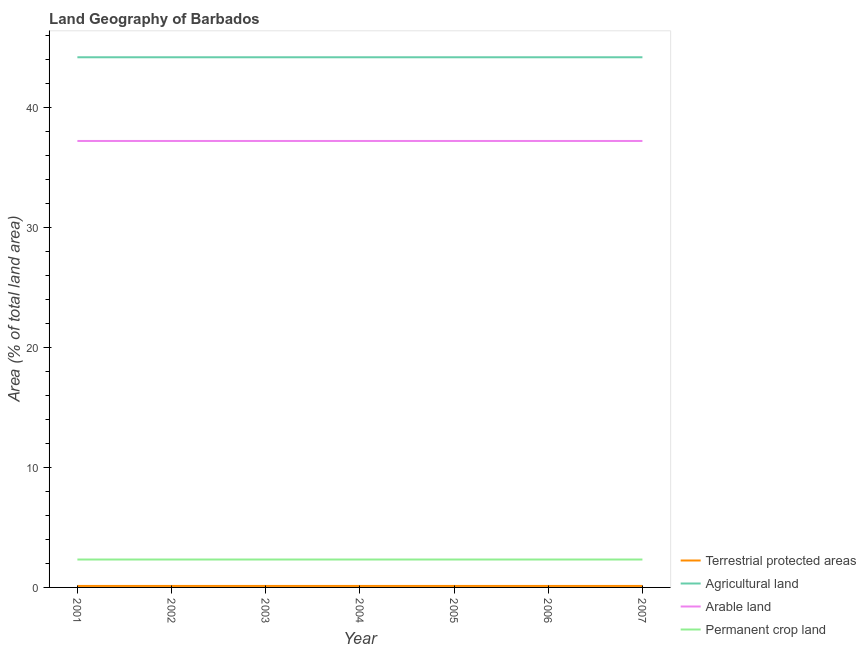Does the line corresponding to percentage of area under permanent crop land intersect with the line corresponding to percentage of area under arable land?
Give a very brief answer. No. What is the percentage of area under arable land in 2003?
Your answer should be compact. 37.21. Across all years, what is the maximum percentage of area under agricultural land?
Offer a terse response. 44.19. Across all years, what is the minimum percentage of land under terrestrial protection?
Provide a short and direct response. 0.12. In which year was the percentage of area under arable land maximum?
Provide a succinct answer. 2001. In which year was the percentage of area under arable land minimum?
Your answer should be very brief. 2001. What is the total percentage of area under arable land in the graph?
Ensure brevity in your answer.  260.47. What is the difference between the percentage of area under agricultural land in 2003 and that in 2004?
Your answer should be very brief. 0. What is the difference between the percentage of area under permanent crop land in 2001 and the percentage of land under terrestrial protection in 2006?
Ensure brevity in your answer.  2.2. What is the average percentage of area under arable land per year?
Your answer should be very brief. 37.21. In the year 2004, what is the difference between the percentage of area under permanent crop land and percentage of area under arable land?
Ensure brevity in your answer.  -34.88. What is the ratio of the percentage of area under agricultural land in 2003 to that in 2007?
Your answer should be very brief. 1. Is the percentage of area under arable land in 2002 less than that in 2005?
Keep it short and to the point. No. What is the difference between the highest and the lowest percentage of area under agricultural land?
Keep it short and to the point. 0. In how many years, is the percentage of area under permanent crop land greater than the average percentage of area under permanent crop land taken over all years?
Offer a terse response. 0. Is the sum of the percentage of area under agricultural land in 2004 and 2007 greater than the maximum percentage of area under permanent crop land across all years?
Give a very brief answer. Yes. Is it the case that in every year, the sum of the percentage of land under terrestrial protection and percentage of area under agricultural land is greater than the percentage of area under arable land?
Your answer should be compact. Yes. What is the difference between two consecutive major ticks on the Y-axis?
Offer a terse response. 10. Where does the legend appear in the graph?
Your response must be concise. Bottom right. What is the title of the graph?
Offer a terse response. Land Geography of Barbados. Does "Fish species" appear as one of the legend labels in the graph?
Give a very brief answer. No. What is the label or title of the Y-axis?
Your answer should be compact. Area (% of total land area). What is the Area (% of total land area) of Terrestrial protected areas in 2001?
Ensure brevity in your answer.  0.12. What is the Area (% of total land area) in Agricultural land in 2001?
Your answer should be very brief. 44.19. What is the Area (% of total land area) in Arable land in 2001?
Keep it short and to the point. 37.21. What is the Area (% of total land area) of Permanent crop land in 2001?
Make the answer very short. 2.33. What is the Area (% of total land area) of Terrestrial protected areas in 2002?
Provide a short and direct response. 0.12. What is the Area (% of total land area) of Agricultural land in 2002?
Ensure brevity in your answer.  44.19. What is the Area (% of total land area) in Arable land in 2002?
Give a very brief answer. 37.21. What is the Area (% of total land area) in Permanent crop land in 2002?
Provide a succinct answer. 2.33. What is the Area (% of total land area) of Terrestrial protected areas in 2003?
Provide a succinct answer. 0.12. What is the Area (% of total land area) of Agricultural land in 2003?
Offer a very short reply. 44.19. What is the Area (% of total land area) of Arable land in 2003?
Provide a short and direct response. 37.21. What is the Area (% of total land area) in Permanent crop land in 2003?
Provide a short and direct response. 2.33. What is the Area (% of total land area) in Terrestrial protected areas in 2004?
Make the answer very short. 0.12. What is the Area (% of total land area) in Agricultural land in 2004?
Provide a succinct answer. 44.19. What is the Area (% of total land area) of Arable land in 2004?
Provide a succinct answer. 37.21. What is the Area (% of total land area) of Permanent crop land in 2004?
Your response must be concise. 2.33. What is the Area (% of total land area) of Terrestrial protected areas in 2005?
Your answer should be compact. 0.12. What is the Area (% of total land area) in Agricultural land in 2005?
Keep it short and to the point. 44.19. What is the Area (% of total land area) in Arable land in 2005?
Offer a very short reply. 37.21. What is the Area (% of total land area) of Permanent crop land in 2005?
Keep it short and to the point. 2.33. What is the Area (% of total land area) in Terrestrial protected areas in 2006?
Make the answer very short. 0.12. What is the Area (% of total land area) in Agricultural land in 2006?
Make the answer very short. 44.19. What is the Area (% of total land area) in Arable land in 2006?
Provide a succinct answer. 37.21. What is the Area (% of total land area) in Permanent crop land in 2006?
Offer a very short reply. 2.33. What is the Area (% of total land area) of Terrestrial protected areas in 2007?
Offer a very short reply. 0.12. What is the Area (% of total land area) of Agricultural land in 2007?
Provide a short and direct response. 44.19. What is the Area (% of total land area) of Arable land in 2007?
Give a very brief answer. 37.21. What is the Area (% of total land area) in Permanent crop land in 2007?
Your answer should be compact. 2.33. Across all years, what is the maximum Area (% of total land area) of Terrestrial protected areas?
Make the answer very short. 0.12. Across all years, what is the maximum Area (% of total land area) of Agricultural land?
Offer a very short reply. 44.19. Across all years, what is the maximum Area (% of total land area) in Arable land?
Ensure brevity in your answer.  37.21. Across all years, what is the maximum Area (% of total land area) in Permanent crop land?
Offer a very short reply. 2.33. Across all years, what is the minimum Area (% of total land area) of Terrestrial protected areas?
Ensure brevity in your answer.  0.12. Across all years, what is the minimum Area (% of total land area) of Agricultural land?
Your answer should be compact. 44.19. Across all years, what is the minimum Area (% of total land area) of Arable land?
Offer a very short reply. 37.21. Across all years, what is the minimum Area (% of total land area) in Permanent crop land?
Provide a short and direct response. 2.33. What is the total Area (% of total land area) of Terrestrial protected areas in the graph?
Offer a terse response. 0.87. What is the total Area (% of total land area) in Agricultural land in the graph?
Ensure brevity in your answer.  309.3. What is the total Area (% of total land area) in Arable land in the graph?
Give a very brief answer. 260.47. What is the total Area (% of total land area) in Permanent crop land in the graph?
Offer a very short reply. 16.28. What is the difference between the Area (% of total land area) in Arable land in 2001 and that in 2002?
Ensure brevity in your answer.  0. What is the difference between the Area (% of total land area) of Agricultural land in 2001 and that in 2003?
Offer a very short reply. 0. What is the difference between the Area (% of total land area) of Arable land in 2001 and that in 2003?
Your answer should be very brief. 0. What is the difference between the Area (% of total land area) in Agricultural land in 2001 and that in 2004?
Your response must be concise. 0. What is the difference between the Area (% of total land area) of Arable land in 2001 and that in 2004?
Make the answer very short. 0. What is the difference between the Area (% of total land area) of Permanent crop land in 2001 and that in 2004?
Provide a succinct answer. 0. What is the difference between the Area (% of total land area) of Terrestrial protected areas in 2001 and that in 2005?
Provide a short and direct response. 0. What is the difference between the Area (% of total land area) of Agricultural land in 2001 and that in 2005?
Your response must be concise. 0. What is the difference between the Area (% of total land area) of Arable land in 2001 and that in 2005?
Offer a terse response. 0. What is the difference between the Area (% of total land area) of Terrestrial protected areas in 2001 and that in 2006?
Give a very brief answer. 0. What is the difference between the Area (% of total land area) of Agricultural land in 2001 and that in 2006?
Keep it short and to the point. 0. What is the difference between the Area (% of total land area) in Arable land in 2001 and that in 2006?
Offer a very short reply. 0. What is the difference between the Area (% of total land area) in Agricultural land in 2001 and that in 2007?
Keep it short and to the point. 0. What is the difference between the Area (% of total land area) of Permanent crop land in 2001 and that in 2007?
Give a very brief answer. 0. What is the difference between the Area (% of total land area) of Terrestrial protected areas in 2002 and that in 2003?
Provide a short and direct response. 0. What is the difference between the Area (% of total land area) in Terrestrial protected areas in 2002 and that in 2004?
Your response must be concise. 0. What is the difference between the Area (% of total land area) of Agricultural land in 2002 and that in 2004?
Offer a terse response. 0. What is the difference between the Area (% of total land area) of Arable land in 2002 and that in 2004?
Offer a very short reply. 0. What is the difference between the Area (% of total land area) in Permanent crop land in 2002 and that in 2004?
Provide a short and direct response. 0. What is the difference between the Area (% of total land area) of Terrestrial protected areas in 2002 and that in 2005?
Offer a very short reply. 0. What is the difference between the Area (% of total land area) of Agricultural land in 2002 and that in 2005?
Your answer should be very brief. 0. What is the difference between the Area (% of total land area) in Arable land in 2002 and that in 2005?
Make the answer very short. 0. What is the difference between the Area (% of total land area) of Permanent crop land in 2002 and that in 2005?
Your answer should be very brief. 0. What is the difference between the Area (% of total land area) of Agricultural land in 2002 and that in 2006?
Ensure brevity in your answer.  0. What is the difference between the Area (% of total land area) of Permanent crop land in 2002 and that in 2006?
Give a very brief answer. 0. What is the difference between the Area (% of total land area) in Arable land in 2002 and that in 2007?
Your answer should be very brief. 0. What is the difference between the Area (% of total land area) in Permanent crop land in 2002 and that in 2007?
Keep it short and to the point. 0. What is the difference between the Area (% of total land area) in Terrestrial protected areas in 2003 and that in 2004?
Your answer should be very brief. 0. What is the difference between the Area (% of total land area) of Agricultural land in 2003 and that in 2004?
Your answer should be very brief. 0. What is the difference between the Area (% of total land area) of Arable land in 2003 and that in 2004?
Give a very brief answer. 0. What is the difference between the Area (% of total land area) of Permanent crop land in 2003 and that in 2004?
Give a very brief answer. 0. What is the difference between the Area (% of total land area) of Agricultural land in 2003 and that in 2005?
Your answer should be compact. 0. What is the difference between the Area (% of total land area) of Agricultural land in 2003 and that in 2006?
Your answer should be very brief. 0. What is the difference between the Area (% of total land area) in Arable land in 2003 and that in 2006?
Offer a very short reply. 0. What is the difference between the Area (% of total land area) in Agricultural land in 2003 and that in 2007?
Make the answer very short. 0. What is the difference between the Area (% of total land area) of Arable land in 2003 and that in 2007?
Your answer should be compact. 0. What is the difference between the Area (% of total land area) in Permanent crop land in 2003 and that in 2007?
Offer a very short reply. 0. What is the difference between the Area (% of total land area) of Agricultural land in 2004 and that in 2005?
Your answer should be compact. 0. What is the difference between the Area (% of total land area) of Permanent crop land in 2004 and that in 2005?
Offer a very short reply. 0. What is the difference between the Area (% of total land area) of Permanent crop land in 2004 and that in 2007?
Ensure brevity in your answer.  0. What is the difference between the Area (% of total land area) in Agricultural land in 2005 and that in 2006?
Ensure brevity in your answer.  0. What is the difference between the Area (% of total land area) of Terrestrial protected areas in 2005 and that in 2007?
Give a very brief answer. 0. What is the difference between the Area (% of total land area) of Agricultural land in 2005 and that in 2007?
Keep it short and to the point. 0. What is the difference between the Area (% of total land area) of Terrestrial protected areas in 2006 and that in 2007?
Ensure brevity in your answer.  0. What is the difference between the Area (% of total land area) in Arable land in 2006 and that in 2007?
Your response must be concise. 0. What is the difference between the Area (% of total land area) in Terrestrial protected areas in 2001 and the Area (% of total land area) in Agricultural land in 2002?
Provide a short and direct response. -44.06. What is the difference between the Area (% of total land area) of Terrestrial protected areas in 2001 and the Area (% of total land area) of Arable land in 2002?
Ensure brevity in your answer.  -37.09. What is the difference between the Area (% of total land area) in Terrestrial protected areas in 2001 and the Area (% of total land area) in Permanent crop land in 2002?
Your response must be concise. -2.2. What is the difference between the Area (% of total land area) of Agricultural land in 2001 and the Area (% of total land area) of Arable land in 2002?
Your response must be concise. 6.98. What is the difference between the Area (% of total land area) of Agricultural land in 2001 and the Area (% of total land area) of Permanent crop land in 2002?
Offer a terse response. 41.86. What is the difference between the Area (% of total land area) in Arable land in 2001 and the Area (% of total land area) in Permanent crop land in 2002?
Provide a short and direct response. 34.88. What is the difference between the Area (% of total land area) in Terrestrial protected areas in 2001 and the Area (% of total land area) in Agricultural land in 2003?
Keep it short and to the point. -44.06. What is the difference between the Area (% of total land area) in Terrestrial protected areas in 2001 and the Area (% of total land area) in Arable land in 2003?
Offer a very short reply. -37.09. What is the difference between the Area (% of total land area) of Terrestrial protected areas in 2001 and the Area (% of total land area) of Permanent crop land in 2003?
Give a very brief answer. -2.2. What is the difference between the Area (% of total land area) of Agricultural land in 2001 and the Area (% of total land area) of Arable land in 2003?
Your answer should be compact. 6.98. What is the difference between the Area (% of total land area) of Agricultural land in 2001 and the Area (% of total land area) of Permanent crop land in 2003?
Ensure brevity in your answer.  41.86. What is the difference between the Area (% of total land area) in Arable land in 2001 and the Area (% of total land area) in Permanent crop land in 2003?
Make the answer very short. 34.88. What is the difference between the Area (% of total land area) in Terrestrial protected areas in 2001 and the Area (% of total land area) in Agricultural land in 2004?
Your answer should be compact. -44.06. What is the difference between the Area (% of total land area) of Terrestrial protected areas in 2001 and the Area (% of total land area) of Arable land in 2004?
Your answer should be very brief. -37.09. What is the difference between the Area (% of total land area) of Terrestrial protected areas in 2001 and the Area (% of total land area) of Permanent crop land in 2004?
Your response must be concise. -2.2. What is the difference between the Area (% of total land area) in Agricultural land in 2001 and the Area (% of total land area) in Arable land in 2004?
Make the answer very short. 6.98. What is the difference between the Area (% of total land area) in Agricultural land in 2001 and the Area (% of total land area) in Permanent crop land in 2004?
Your answer should be very brief. 41.86. What is the difference between the Area (% of total land area) of Arable land in 2001 and the Area (% of total land area) of Permanent crop land in 2004?
Offer a terse response. 34.88. What is the difference between the Area (% of total land area) in Terrestrial protected areas in 2001 and the Area (% of total land area) in Agricultural land in 2005?
Your answer should be very brief. -44.06. What is the difference between the Area (% of total land area) of Terrestrial protected areas in 2001 and the Area (% of total land area) of Arable land in 2005?
Provide a succinct answer. -37.09. What is the difference between the Area (% of total land area) in Terrestrial protected areas in 2001 and the Area (% of total land area) in Permanent crop land in 2005?
Offer a terse response. -2.2. What is the difference between the Area (% of total land area) of Agricultural land in 2001 and the Area (% of total land area) of Arable land in 2005?
Make the answer very short. 6.98. What is the difference between the Area (% of total land area) of Agricultural land in 2001 and the Area (% of total land area) of Permanent crop land in 2005?
Offer a very short reply. 41.86. What is the difference between the Area (% of total land area) in Arable land in 2001 and the Area (% of total land area) in Permanent crop land in 2005?
Your answer should be compact. 34.88. What is the difference between the Area (% of total land area) of Terrestrial protected areas in 2001 and the Area (% of total land area) of Agricultural land in 2006?
Ensure brevity in your answer.  -44.06. What is the difference between the Area (% of total land area) in Terrestrial protected areas in 2001 and the Area (% of total land area) in Arable land in 2006?
Offer a terse response. -37.09. What is the difference between the Area (% of total land area) of Terrestrial protected areas in 2001 and the Area (% of total land area) of Permanent crop land in 2006?
Your answer should be very brief. -2.2. What is the difference between the Area (% of total land area) of Agricultural land in 2001 and the Area (% of total land area) of Arable land in 2006?
Make the answer very short. 6.98. What is the difference between the Area (% of total land area) of Agricultural land in 2001 and the Area (% of total land area) of Permanent crop land in 2006?
Give a very brief answer. 41.86. What is the difference between the Area (% of total land area) of Arable land in 2001 and the Area (% of total land area) of Permanent crop land in 2006?
Offer a very short reply. 34.88. What is the difference between the Area (% of total land area) in Terrestrial protected areas in 2001 and the Area (% of total land area) in Agricultural land in 2007?
Offer a terse response. -44.06. What is the difference between the Area (% of total land area) of Terrestrial protected areas in 2001 and the Area (% of total land area) of Arable land in 2007?
Your answer should be compact. -37.09. What is the difference between the Area (% of total land area) of Terrestrial protected areas in 2001 and the Area (% of total land area) of Permanent crop land in 2007?
Give a very brief answer. -2.2. What is the difference between the Area (% of total land area) in Agricultural land in 2001 and the Area (% of total land area) in Arable land in 2007?
Your answer should be very brief. 6.98. What is the difference between the Area (% of total land area) of Agricultural land in 2001 and the Area (% of total land area) of Permanent crop land in 2007?
Your response must be concise. 41.86. What is the difference between the Area (% of total land area) in Arable land in 2001 and the Area (% of total land area) in Permanent crop land in 2007?
Give a very brief answer. 34.88. What is the difference between the Area (% of total land area) of Terrestrial protected areas in 2002 and the Area (% of total land area) of Agricultural land in 2003?
Ensure brevity in your answer.  -44.06. What is the difference between the Area (% of total land area) of Terrestrial protected areas in 2002 and the Area (% of total land area) of Arable land in 2003?
Offer a very short reply. -37.09. What is the difference between the Area (% of total land area) of Terrestrial protected areas in 2002 and the Area (% of total land area) of Permanent crop land in 2003?
Your response must be concise. -2.2. What is the difference between the Area (% of total land area) of Agricultural land in 2002 and the Area (% of total land area) of Arable land in 2003?
Keep it short and to the point. 6.98. What is the difference between the Area (% of total land area) in Agricultural land in 2002 and the Area (% of total land area) in Permanent crop land in 2003?
Offer a terse response. 41.86. What is the difference between the Area (% of total land area) in Arable land in 2002 and the Area (% of total land area) in Permanent crop land in 2003?
Give a very brief answer. 34.88. What is the difference between the Area (% of total land area) of Terrestrial protected areas in 2002 and the Area (% of total land area) of Agricultural land in 2004?
Your answer should be very brief. -44.06. What is the difference between the Area (% of total land area) in Terrestrial protected areas in 2002 and the Area (% of total land area) in Arable land in 2004?
Your response must be concise. -37.09. What is the difference between the Area (% of total land area) in Terrestrial protected areas in 2002 and the Area (% of total land area) in Permanent crop land in 2004?
Keep it short and to the point. -2.2. What is the difference between the Area (% of total land area) in Agricultural land in 2002 and the Area (% of total land area) in Arable land in 2004?
Ensure brevity in your answer.  6.98. What is the difference between the Area (% of total land area) in Agricultural land in 2002 and the Area (% of total land area) in Permanent crop land in 2004?
Your response must be concise. 41.86. What is the difference between the Area (% of total land area) of Arable land in 2002 and the Area (% of total land area) of Permanent crop land in 2004?
Provide a succinct answer. 34.88. What is the difference between the Area (% of total land area) of Terrestrial protected areas in 2002 and the Area (% of total land area) of Agricultural land in 2005?
Provide a short and direct response. -44.06. What is the difference between the Area (% of total land area) in Terrestrial protected areas in 2002 and the Area (% of total land area) in Arable land in 2005?
Offer a terse response. -37.09. What is the difference between the Area (% of total land area) of Terrestrial protected areas in 2002 and the Area (% of total land area) of Permanent crop land in 2005?
Keep it short and to the point. -2.2. What is the difference between the Area (% of total land area) of Agricultural land in 2002 and the Area (% of total land area) of Arable land in 2005?
Your response must be concise. 6.98. What is the difference between the Area (% of total land area) of Agricultural land in 2002 and the Area (% of total land area) of Permanent crop land in 2005?
Provide a short and direct response. 41.86. What is the difference between the Area (% of total land area) of Arable land in 2002 and the Area (% of total land area) of Permanent crop land in 2005?
Your response must be concise. 34.88. What is the difference between the Area (% of total land area) in Terrestrial protected areas in 2002 and the Area (% of total land area) in Agricultural land in 2006?
Provide a succinct answer. -44.06. What is the difference between the Area (% of total land area) in Terrestrial protected areas in 2002 and the Area (% of total land area) in Arable land in 2006?
Offer a very short reply. -37.09. What is the difference between the Area (% of total land area) in Terrestrial protected areas in 2002 and the Area (% of total land area) in Permanent crop land in 2006?
Your response must be concise. -2.2. What is the difference between the Area (% of total land area) in Agricultural land in 2002 and the Area (% of total land area) in Arable land in 2006?
Make the answer very short. 6.98. What is the difference between the Area (% of total land area) in Agricultural land in 2002 and the Area (% of total land area) in Permanent crop land in 2006?
Provide a succinct answer. 41.86. What is the difference between the Area (% of total land area) in Arable land in 2002 and the Area (% of total land area) in Permanent crop land in 2006?
Your response must be concise. 34.88. What is the difference between the Area (% of total land area) in Terrestrial protected areas in 2002 and the Area (% of total land area) in Agricultural land in 2007?
Your answer should be very brief. -44.06. What is the difference between the Area (% of total land area) in Terrestrial protected areas in 2002 and the Area (% of total land area) in Arable land in 2007?
Make the answer very short. -37.09. What is the difference between the Area (% of total land area) in Terrestrial protected areas in 2002 and the Area (% of total land area) in Permanent crop land in 2007?
Your answer should be compact. -2.2. What is the difference between the Area (% of total land area) in Agricultural land in 2002 and the Area (% of total land area) in Arable land in 2007?
Ensure brevity in your answer.  6.98. What is the difference between the Area (% of total land area) in Agricultural land in 2002 and the Area (% of total land area) in Permanent crop land in 2007?
Make the answer very short. 41.86. What is the difference between the Area (% of total land area) in Arable land in 2002 and the Area (% of total land area) in Permanent crop land in 2007?
Offer a terse response. 34.88. What is the difference between the Area (% of total land area) in Terrestrial protected areas in 2003 and the Area (% of total land area) in Agricultural land in 2004?
Provide a succinct answer. -44.06. What is the difference between the Area (% of total land area) in Terrestrial protected areas in 2003 and the Area (% of total land area) in Arable land in 2004?
Make the answer very short. -37.09. What is the difference between the Area (% of total land area) of Terrestrial protected areas in 2003 and the Area (% of total land area) of Permanent crop land in 2004?
Your answer should be compact. -2.2. What is the difference between the Area (% of total land area) of Agricultural land in 2003 and the Area (% of total land area) of Arable land in 2004?
Your answer should be compact. 6.98. What is the difference between the Area (% of total land area) in Agricultural land in 2003 and the Area (% of total land area) in Permanent crop land in 2004?
Provide a short and direct response. 41.86. What is the difference between the Area (% of total land area) of Arable land in 2003 and the Area (% of total land area) of Permanent crop land in 2004?
Offer a terse response. 34.88. What is the difference between the Area (% of total land area) in Terrestrial protected areas in 2003 and the Area (% of total land area) in Agricultural land in 2005?
Offer a terse response. -44.06. What is the difference between the Area (% of total land area) of Terrestrial protected areas in 2003 and the Area (% of total land area) of Arable land in 2005?
Offer a very short reply. -37.09. What is the difference between the Area (% of total land area) in Terrestrial protected areas in 2003 and the Area (% of total land area) in Permanent crop land in 2005?
Offer a very short reply. -2.2. What is the difference between the Area (% of total land area) of Agricultural land in 2003 and the Area (% of total land area) of Arable land in 2005?
Your response must be concise. 6.98. What is the difference between the Area (% of total land area) in Agricultural land in 2003 and the Area (% of total land area) in Permanent crop land in 2005?
Offer a very short reply. 41.86. What is the difference between the Area (% of total land area) of Arable land in 2003 and the Area (% of total land area) of Permanent crop land in 2005?
Offer a terse response. 34.88. What is the difference between the Area (% of total land area) in Terrestrial protected areas in 2003 and the Area (% of total land area) in Agricultural land in 2006?
Ensure brevity in your answer.  -44.06. What is the difference between the Area (% of total land area) in Terrestrial protected areas in 2003 and the Area (% of total land area) in Arable land in 2006?
Your response must be concise. -37.09. What is the difference between the Area (% of total land area) of Terrestrial protected areas in 2003 and the Area (% of total land area) of Permanent crop land in 2006?
Provide a succinct answer. -2.2. What is the difference between the Area (% of total land area) of Agricultural land in 2003 and the Area (% of total land area) of Arable land in 2006?
Your answer should be compact. 6.98. What is the difference between the Area (% of total land area) in Agricultural land in 2003 and the Area (% of total land area) in Permanent crop land in 2006?
Provide a succinct answer. 41.86. What is the difference between the Area (% of total land area) of Arable land in 2003 and the Area (% of total land area) of Permanent crop land in 2006?
Ensure brevity in your answer.  34.88. What is the difference between the Area (% of total land area) in Terrestrial protected areas in 2003 and the Area (% of total land area) in Agricultural land in 2007?
Your response must be concise. -44.06. What is the difference between the Area (% of total land area) in Terrestrial protected areas in 2003 and the Area (% of total land area) in Arable land in 2007?
Offer a very short reply. -37.09. What is the difference between the Area (% of total land area) in Terrestrial protected areas in 2003 and the Area (% of total land area) in Permanent crop land in 2007?
Ensure brevity in your answer.  -2.2. What is the difference between the Area (% of total land area) of Agricultural land in 2003 and the Area (% of total land area) of Arable land in 2007?
Provide a succinct answer. 6.98. What is the difference between the Area (% of total land area) of Agricultural land in 2003 and the Area (% of total land area) of Permanent crop land in 2007?
Keep it short and to the point. 41.86. What is the difference between the Area (% of total land area) in Arable land in 2003 and the Area (% of total land area) in Permanent crop land in 2007?
Provide a succinct answer. 34.88. What is the difference between the Area (% of total land area) in Terrestrial protected areas in 2004 and the Area (% of total land area) in Agricultural land in 2005?
Your response must be concise. -44.06. What is the difference between the Area (% of total land area) of Terrestrial protected areas in 2004 and the Area (% of total land area) of Arable land in 2005?
Provide a succinct answer. -37.09. What is the difference between the Area (% of total land area) in Terrestrial protected areas in 2004 and the Area (% of total land area) in Permanent crop land in 2005?
Provide a succinct answer. -2.2. What is the difference between the Area (% of total land area) of Agricultural land in 2004 and the Area (% of total land area) of Arable land in 2005?
Provide a short and direct response. 6.98. What is the difference between the Area (% of total land area) in Agricultural land in 2004 and the Area (% of total land area) in Permanent crop land in 2005?
Provide a short and direct response. 41.86. What is the difference between the Area (% of total land area) of Arable land in 2004 and the Area (% of total land area) of Permanent crop land in 2005?
Give a very brief answer. 34.88. What is the difference between the Area (% of total land area) in Terrestrial protected areas in 2004 and the Area (% of total land area) in Agricultural land in 2006?
Your answer should be compact. -44.06. What is the difference between the Area (% of total land area) in Terrestrial protected areas in 2004 and the Area (% of total land area) in Arable land in 2006?
Your answer should be very brief. -37.09. What is the difference between the Area (% of total land area) of Terrestrial protected areas in 2004 and the Area (% of total land area) of Permanent crop land in 2006?
Offer a terse response. -2.2. What is the difference between the Area (% of total land area) in Agricultural land in 2004 and the Area (% of total land area) in Arable land in 2006?
Your response must be concise. 6.98. What is the difference between the Area (% of total land area) of Agricultural land in 2004 and the Area (% of total land area) of Permanent crop land in 2006?
Your answer should be very brief. 41.86. What is the difference between the Area (% of total land area) in Arable land in 2004 and the Area (% of total land area) in Permanent crop land in 2006?
Provide a short and direct response. 34.88. What is the difference between the Area (% of total land area) in Terrestrial protected areas in 2004 and the Area (% of total land area) in Agricultural land in 2007?
Offer a terse response. -44.06. What is the difference between the Area (% of total land area) of Terrestrial protected areas in 2004 and the Area (% of total land area) of Arable land in 2007?
Your answer should be compact. -37.09. What is the difference between the Area (% of total land area) of Terrestrial protected areas in 2004 and the Area (% of total land area) of Permanent crop land in 2007?
Keep it short and to the point. -2.2. What is the difference between the Area (% of total land area) in Agricultural land in 2004 and the Area (% of total land area) in Arable land in 2007?
Make the answer very short. 6.98. What is the difference between the Area (% of total land area) of Agricultural land in 2004 and the Area (% of total land area) of Permanent crop land in 2007?
Provide a short and direct response. 41.86. What is the difference between the Area (% of total land area) of Arable land in 2004 and the Area (% of total land area) of Permanent crop land in 2007?
Your response must be concise. 34.88. What is the difference between the Area (% of total land area) of Terrestrial protected areas in 2005 and the Area (% of total land area) of Agricultural land in 2006?
Provide a succinct answer. -44.06. What is the difference between the Area (% of total land area) of Terrestrial protected areas in 2005 and the Area (% of total land area) of Arable land in 2006?
Your response must be concise. -37.09. What is the difference between the Area (% of total land area) in Terrestrial protected areas in 2005 and the Area (% of total land area) in Permanent crop land in 2006?
Your answer should be very brief. -2.2. What is the difference between the Area (% of total land area) of Agricultural land in 2005 and the Area (% of total land area) of Arable land in 2006?
Keep it short and to the point. 6.98. What is the difference between the Area (% of total land area) of Agricultural land in 2005 and the Area (% of total land area) of Permanent crop land in 2006?
Make the answer very short. 41.86. What is the difference between the Area (% of total land area) of Arable land in 2005 and the Area (% of total land area) of Permanent crop land in 2006?
Provide a short and direct response. 34.88. What is the difference between the Area (% of total land area) in Terrestrial protected areas in 2005 and the Area (% of total land area) in Agricultural land in 2007?
Offer a very short reply. -44.06. What is the difference between the Area (% of total land area) of Terrestrial protected areas in 2005 and the Area (% of total land area) of Arable land in 2007?
Offer a very short reply. -37.09. What is the difference between the Area (% of total land area) of Terrestrial protected areas in 2005 and the Area (% of total land area) of Permanent crop land in 2007?
Your response must be concise. -2.2. What is the difference between the Area (% of total land area) in Agricultural land in 2005 and the Area (% of total land area) in Arable land in 2007?
Your answer should be very brief. 6.98. What is the difference between the Area (% of total land area) of Agricultural land in 2005 and the Area (% of total land area) of Permanent crop land in 2007?
Offer a very short reply. 41.86. What is the difference between the Area (% of total land area) in Arable land in 2005 and the Area (% of total land area) in Permanent crop land in 2007?
Your response must be concise. 34.88. What is the difference between the Area (% of total land area) of Terrestrial protected areas in 2006 and the Area (% of total land area) of Agricultural land in 2007?
Give a very brief answer. -44.06. What is the difference between the Area (% of total land area) of Terrestrial protected areas in 2006 and the Area (% of total land area) of Arable land in 2007?
Provide a succinct answer. -37.09. What is the difference between the Area (% of total land area) of Terrestrial protected areas in 2006 and the Area (% of total land area) of Permanent crop land in 2007?
Your answer should be compact. -2.2. What is the difference between the Area (% of total land area) in Agricultural land in 2006 and the Area (% of total land area) in Arable land in 2007?
Keep it short and to the point. 6.98. What is the difference between the Area (% of total land area) in Agricultural land in 2006 and the Area (% of total land area) in Permanent crop land in 2007?
Keep it short and to the point. 41.86. What is the difference between the Area (% of total land area) in Arable land in 2006 and the Area (% of total land area) in Permanent crop land in 2007?
Provide a succinct answer. 34.88. What is the average Area (% of total land area) in Terrestrial protected areas per year?
Give a very brief answer. 0.12. What is the average Area (% of total land area) in Agricultural land per year?
Make the answer very short. 44.19. What is the average Area (% of total land area) of Arable land per year?
Your response must be concise. 37.21. What is the average Area (% of total land area) in Permanent crop land per year?
Give a very brief answer. 2.33. In the year 2001, what is the difference between the Area (% of total land area) in Terrestrial protected areas and Area (% of total land area) in Agricultural land?
Your answer should be compact. -44.06. In the year 2001, what is the difference between the Area (% of total land area) in Terrestrial protected areas and Area (% of total land area) in Arable land?
Ensure brevity in your answer.  -37.09. In the year 2001, what is the difference between the Area (% of total land area) of Terrestrial protected areas and Area (% of total land area) of Permanent crop land?
Your response must be concise. -2.2. In the year 2001, what is the difference between the Area (% of total land area) in Agricultural land and Area (% of total land area) in Arable land?
Offer a terse response. 6.98. In the year 2001, what is the difference between the Area (% of total land area) of Agricultural land and Area (% of total land area) of Permanent crop land?
Make the answer very short. 41.86. In the year 2001, what is the difference between the Area (% of total land area) in Arable land and Area (% of total land area) in Permanent crop land?
Offer a terse response. 34.88. In the year 2002, what is the difference between the Area (% of total land area) of Terrestrial protected areas and Area (% of total land area) of Agricultural land?
Provide a succinct answer. -44.06. In the year 2002, what is the difference between the Area (% of total land area) in Terrestrial protected areas and Area (% of total land area) in Arable land?
Offer a terse response. -37.09. In the year 2002, what is the difference between the Area (% of total land area) in Terrestrial protected areas and Area (% of total land area) in Permanent crop land?
Your response must be concise. -2.2. In the year 2002, what is the difference between the Area (% of total land area) of Agricultural land and Area (% of total land area) of Arable land?
Provide a short and direct response. 6.98. In the year 2002, what is the difference between the Area (% of total land area) of Agricultural land and Area (% of total land area) of Permanent crop land?
Your answer should be very brief. 41.86. In the year 2002, what is the difference between the Area (% of total land area) in Arable land and Area (% of total land area) in Permanent crop land?
Keep it short and to the point. 34.88. In the year 2003, what is the difference between the Area (% of total land area) in Terrestrial protected areas and Area (% of total land area) in Agricultural land?
Your answer should be very brief. -44.06. In the year 2003, what is the difference between the Area (% of total land area) of Terrestrial protected areas and Area (% of total land area) of Arable land?
Give a very brief answer. -37.09. In the year 2003, what is the difference between the Area (% of total land area) of Terrestrial protected areas and Area (% of total land area) of Permanent crop land?
Provide a short and direct response. -2.2. In the year 2003, what is the difference between the Area (% of total land area) in Agricultural land and Area (% of total land area) in Arable land?
Your response must be concise. 6.98. In the year 2003, what is the difference between the Area (% of total land area) in Agricultural land and Area (% of total land area) in Permanent crop land?
Your response must be concise. 41.86. In the year 2003, what is the difference between the Area (% of total land area) of Arable land and Area (% of total land area) of Permanent crop land?
Your response must be concise. 34.88. In the year 2004, what is the difference between the Area (% of total land area) in Terrestrial protected areas and Area (% of total land area) in Agricultural land?
Offer a very short reply. -44.06. In the year 2004, what is the difference between the Area (% of total land area) in Terrestrial protected areas and Area (% of total land area) in Arable land?
Your answer should be compact. -37.09. In the year 2004, what is the difference between the Area (% of total land area) of Terrestrial protected areas and Area (% of total land area) of Permanent crop land?
Give a very brief answer. -2.2. In the year 2004, what is the difference between the Area (% of total land area) in Agricultural land and Area (% of total land area) in Arable land?
Offer a terse response. 6.98. In the year 2004, what is the difference between the Area (% of total land area) of Agricultural land and Area (% of total land area) of Permanent crop land?
Offer a very short reply. 41.86. In the year 2004, what is the difference between the Area (% of total land area) of Arable land and Area (% of total land area) of Permanent crop land?
Your response must be concise. 34.88. In the year 2005, what is the difference between the Area (% of total land area) in Terrestrial protected areas and Area (% of total land area) in Agricultural land?
Offer a very short reply. -44.06. In the year 2005, what is the difference between the Area (% of total land area) of Terrestrial protected areas and Area (% of total land area) of Arable land?
Give a very brief answer. -37.09. In the year 2005, what is the difference between the Area (% of total land area) in Terrestrial protected areas and Area (% of total land area) in Permanent crop land?
Provide a short and direct response. -2.2. In the year 2005, what is the difference between the Area (% of total land area) of Agricultural land and Area (% of total land area) of Arable land?
Make the answer very short. 6.98. In the year 2005, what is the difference between the Area (% of total land area) in Agricultural land and Area (% of total land area) in Permanent crop land?
Your answer should be very brief. 41.86. In the year 2005, what is the difference between the Area (% of total land area) of Arable land and Area (% of total land area) of Permanent crop land?
Offer a very short reply. 34.88. In the year 2006, what is the difference between the Area (% of total land area) of Terrestrial protected areas and Area (% of total land area) of Agricultural land?
Keep it short and to the point. -44.06. In the year 2006, what is the difference between the Area (% of total land area) of Terrestrial protected areas and Area (% of total land area) of Arable land?
Keep it short and to the point. -37.09. In the year 2006, what is the difference between the Area (% of total land area) in Terrestrial protected areas and Area (% of total land area) in Permanent crop land?
Keep it short and to the point. -2.2. In the year 2006, what is the difference between the Area (% of total land area) of Agricultural land and Area (% of total land area) of Arable land?
Keep it short and to the point. 6.98. In the year 2006, what is the difference between the Area (% of total land area) in Agricultural land and Area (% of total land area) in Permanent crop land?
Ensure brevity in your answer.  41.86. In the year 2006, what is the difference between the Area (% of total land area) of Arable land and Area (% of total land area) of Permanent crop land?
Offer a terse response. 34.88. In the year 2007, what is the difference between the Area (% of total land area) in Terrestrial protected areas and Area (% of total land area) in Agricultural land?
Make the answer very short. -44.06. In the year 2007, what is the difference between the Area (% of total land area) in Terrestrial protected areas and Area (% of total land area) in Arable land?
Your response must be concise. -37.09. In the year 2007, what is the difference between the Area (% of total land area) in Terrestrial protected areas and Area (% of total land area) in Permanent crop land?
Provide a succinct answer. -2.2. In the year 2007, what is the difference between the Area (% of total land area) of Agricultural land and Area (% of total land area) of Arable land?
Make the answer very short. 6.98. In the year 2007, what is the difference between the Area (% of total land area) of Agricultural land and Area (% of total land area) of Permanent crop land?
Keep it short and to the point. 41.86. In the year 2007, what is the difference between the Area (% of total land area) of Arable land and Area (% of total land area) of Permanent crop land?
Provide a short and direct response. 34.88. What is the ratio of the Area (% of total land area) in Arable land in 2001 to that in 2002?
Ensure brevity in your answer.  1. What is the ratio of the Area (% of total land area) in Permanent crop land in 2001 to that in 2002?
Your response must be concise. 1. What is the ratio of the Area (% of total land area) in Agricultural land in 2001 to that in 2003?
Your response must be concise. 1. What is the ratio of the Area (% of total land area) in Arable land in 2001 to that in 2003?
Offer a very short reply. 1. What is the ratio of the Area (% of total land area) in Arable land in 2001 to that in 2004?
Your answer should be very brief. 1. What is the ratio of the Area (% of total land area) of Permanent crop land in 2001 to that in 2004?
Your answer should be very brief. 1. What is the ratio of the Area (% of total land area) of Agricultural land in 2001 to that in 2005?
Your response must be concise. 1. What is the ratio of the Area (% of total land area) of Permanent crop land in 2001 to that in 2005?
Your response must be concise. 1. What is the ratio of the Area (% of total land area) in Agricultural land in 2001 to that in 2006?
Your response must be concise. 1. What is the ratio of the Area (% of total land area) of Arable land in 2001 to that in 2006?
Ensure brevity in your answer.  1. What is the ratio of the Area (% of total land area) of Agricultural land in 2001 to that in 2007?
Your response must be concise. 1. What is the ratio of the Area (% of total land area) of Arable land in 2001 to that in 2007?
Provide a succinct answer. 1. What is the ratio of the Area (% of total land area) in Permanent crop land in 2001 to that in 2007?
Give a very brief answer. 1. What is the ratio of the Area (% of total land area) of Permanent crop land in 2002 to that in 2003?
Offer a very short reply. 1. What is the ratio of the Area (% of total land area) in Terrestrial protected areas in 2002 to that in 2005?
Keep it short and to the point. 1. What is the ratio of the Area (% of total land area) in Agricultural land in 2002 to that in 2005?
Provide a succinct answer. 1. What is the ratio of the Area (% of total land area) in Permanent crop land in 2002 to that in 2005?
Offer a very short reply. 1. What is the ratio of the Area (% of total land area) of Agricultural land in 2002 to that in 2006?
Offer a terse response. 1. What is the ratio of the Area (% of total land area) of Terrestrial protected areas in 2002 to that in 2007?
Provide a succinct answer. 1. What is the ratio of the Area (% of total land area) of Permanent crop land in 2002 to that in 2007?
Offer a very short reply. 1. What is the ratio of the Area (% of total land area) in Terrestrial protected areas in 2003 to that in 2004?
Offer a very short reply. 1. What is the ratio of the Area (% of total land area) of Agricultural land in 2003 to that in 2004?
Offer a terse response. 1. What is the ratio of the Area (% of total land area) of Agricultural land in 2003 to that in 2005?
Give a very brief answer. 1. What is the ratio of the Area (% of total land area) of Arable land in 2003 to that in 2005?
Give a very brief answer. 1. What is the ratio of the Area (% of total land area) of Permanent crop land in 2003 to that in 2005?
Give a very brief answer. 1. What is the ratio of the Area (% of total land area) in Terrestrial protected areas in 2003 to that in 2006?
Keep it short and to the point. 1. What is the ratio of the Area (% of total land area) of Agricultural land in 2003 to that in 2006?
Your answer should be compact. 1. What is the ratio of the Area (% of total land area) of Agricultural land in 2003 to that in 2007?
Ensure brevity in your answer.  1. What is the ratio of the Area (% of total land area) in Permanent crop land in 2003 to that in 2007?
Offer a terse response. 1. What is the ratio of the Area (% of total land area) of Agricultural land in 2004 to that in 2005?
Your response must be concise. 1. What is the ratio of the Area (% of total land area) in Agricultural land in 2004 to that in 2006?
Provide a succinct answer. 1. What is the ratio of the Area (% of total land area) in Permanent crop land in 2004 to that in 2006?
Keep it short and to the point. 1. What is the ratio of the Area (% of total land area) of Terrestrial protected areas in 2004 to that in 2007?
Ensure brevity in your answer.  1. What is the ratio of the Area (% of total land area) of Agricultural land in 2004 to that in 2007?
Provide a succinct answer. 1. What is the ratio of the Area (% of total land area) in Agricultural land in 2005 to that in 2006?
Make the answer very short. 1. What is the ratio of the Area (% of total land area) in Terrestrial protected areas in 2005 to that in 2007?
Ensure brevity in your answer.  1. What is the ratio of the Area (% of total land area) in Permanent crop land in 2005 to that in 2007?
Your answer should be compact. 1. What is the ratio of the Area (% of total land area) in Terrestrial protected areas in 2006 to that in 2007?
Give a very brief answer. 1. What is the ratio of the Area (% of total land area) in Agricultural land in 2006 to that in 2007?
Your answer should be compact. 1. What is the ratio of the Area (% of total land area) in Permanent crop land in 2006 to that in 2007?
Your answer should be compact. 1. What is the difference between the highest and the second highest Area (% of total land area) in Terrestrial protected areas?
Offer a very short reply. 0. 